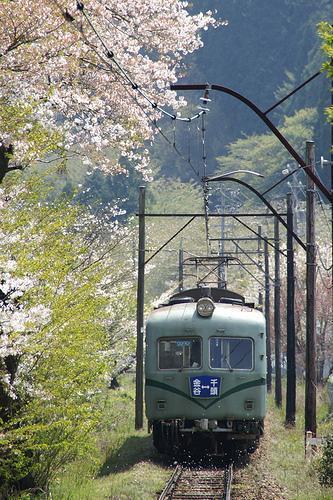How many windows are on the front of the train?
Give a very brief answer. 2. 